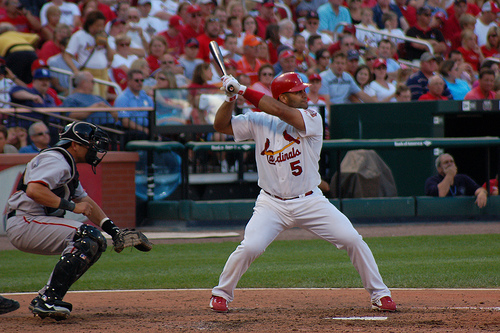What part of the game do you think this is? Given the batter's focused stance and preparedness, it could be any critical moment during the game. It's not possible to determine the exact part of the game without additional context, but typically such concentration is seen during key at-bats which could be in any inning where scoring runs is crucial. 